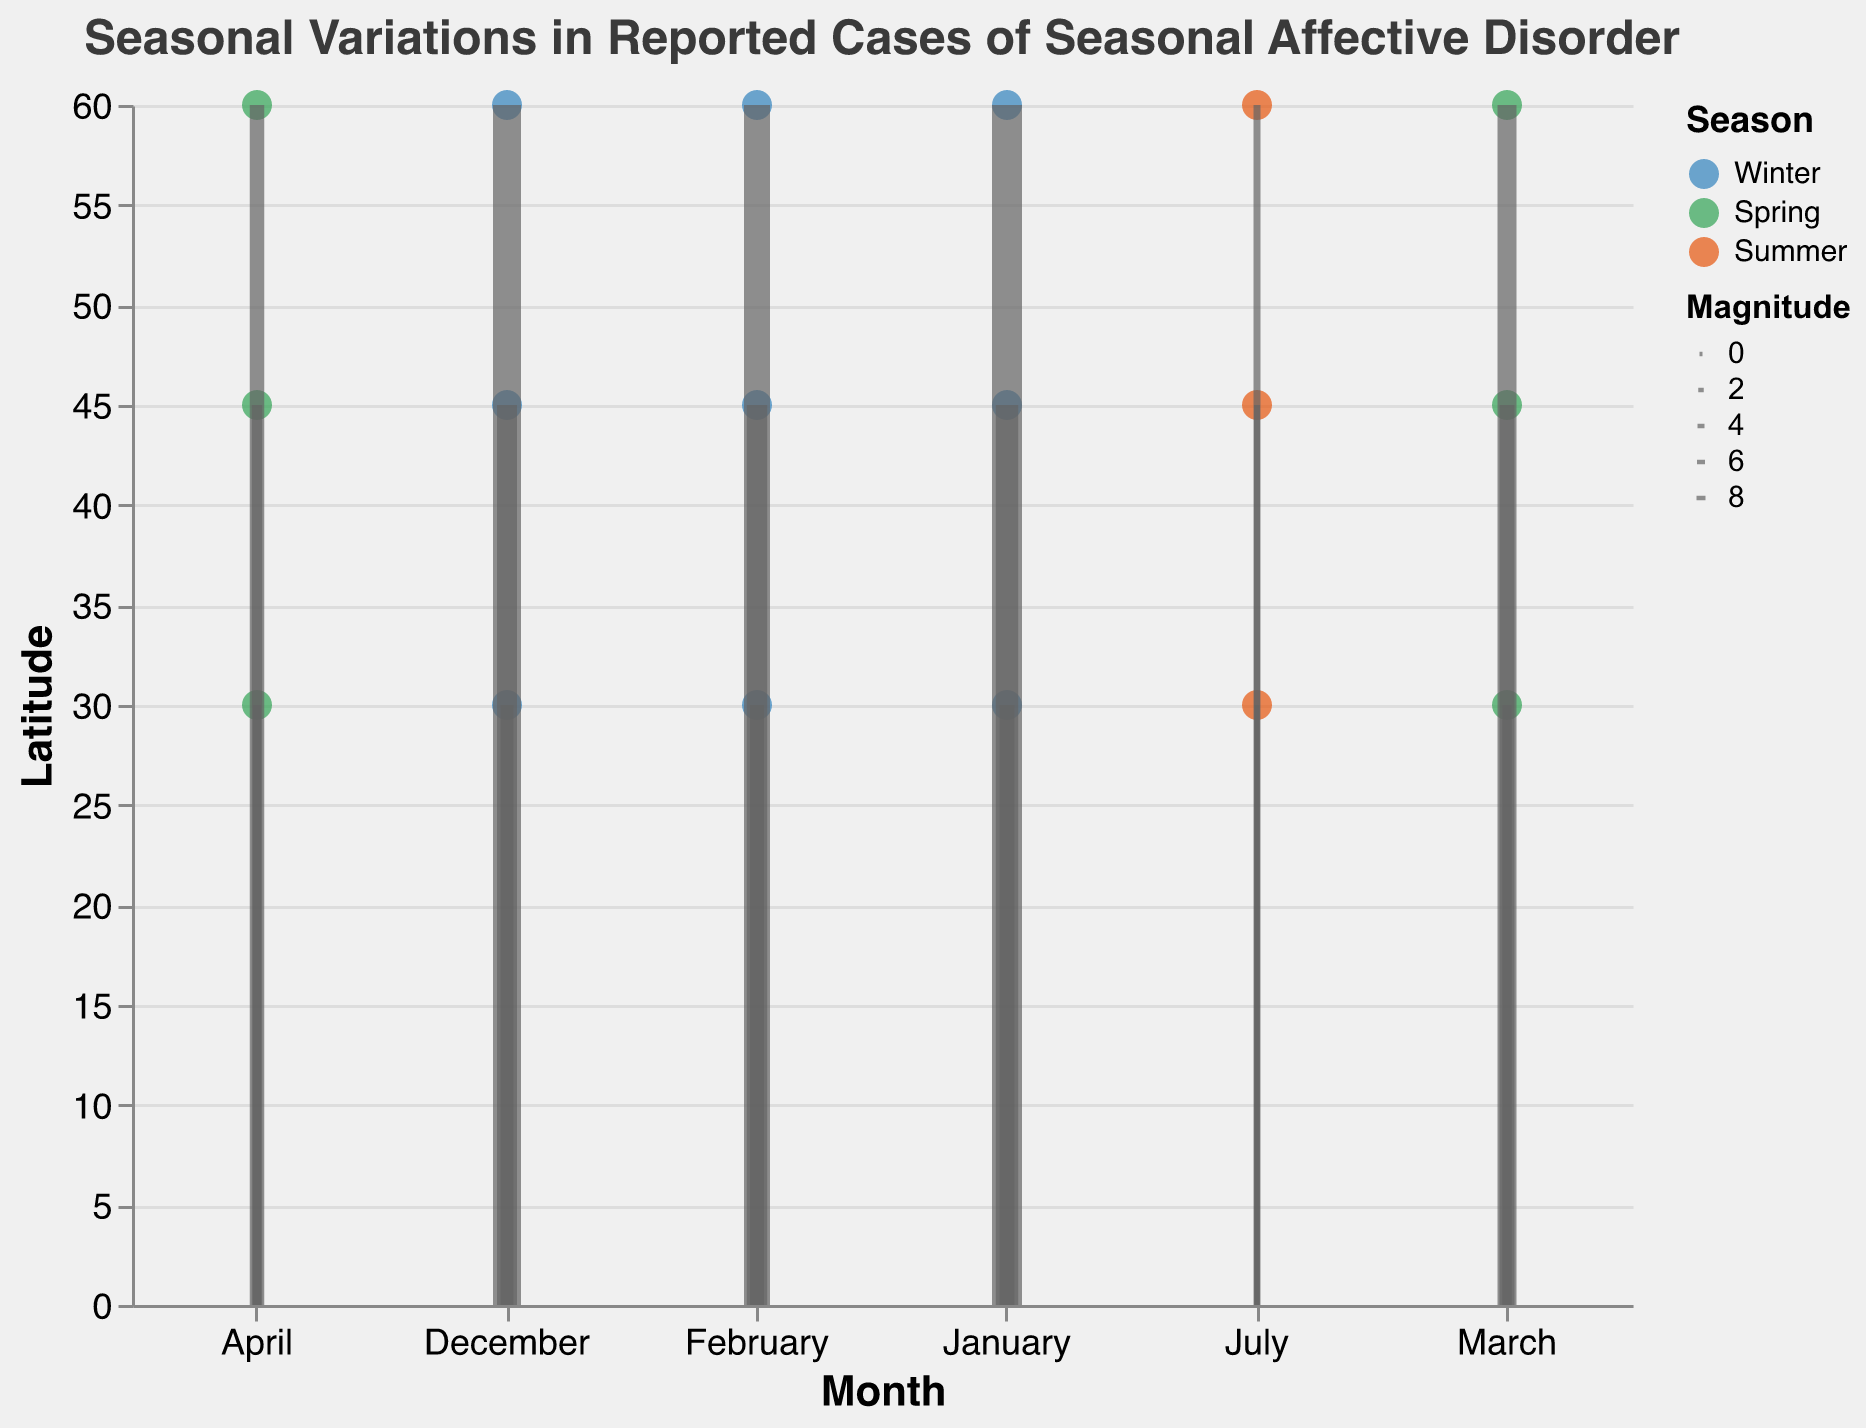What is the title of the figure? The title of the figure is displayed prominently at the top of the plot.
Answer: Seasonal Variations in Reported Cases of Seasonal Affective Disorder How is the 'Direction' of wind visualized in the figure? The 'Direction' is visualized through the orientation of the wind vector arrows marked as 'rule'. Each direction corresponds to a specific angle: North (0°), Northeast (45°), East (90°), Southeast (135°), South (180°), and Northwest (315°).
Answer: Through the orientation of wind vector arrows Which season has the most reported cases of Seasonal Affective Disorder at latitude 60.0? Checking the colors representing seasons and the values for reported cases at latitude 60.0, the winter season (blue color) shows the highest values in December, January, and February. The highest number of cases is in January.
Answer: Winter Comparing January at latitudes 60.0 and 30.0, which has more reported cases? Look at the points for January at both latitudes. For 60.0 (blue point), reported cases are 187. For 30.0 (blue point), reported cases are 53.
Answer: Latitude 60.0 What month has the lowest number of reported cases of Seasonal Affective Disorder? Checking all months visually, the lowest number of reported cases is observed in July (summer season, orange color) across all latitudes.
Answer: July How many data points are plotted in the figure? Counting all the individual data points plotted for various months and latitudes, there are 18 points corresponding to different months and latitudes.
Answer: 18 During which season and month is the intensity of the disorder lowest at latitude 45.0? Look at the sizes of the points at latitude 45.0. The smallest size point is in July, indicating the lowest intensity during the summer.
Answer: Summer, July What is the direction and magnitude of the wind vector in January at latitude 45.0? Locate the wind vector arrow for January at 45.0. The arrow points towards the North (0°) with a magnitude size represented as 6.1.
Answer: North, 6.1 Which latitude experienced a sharper decrease in reported cases from Winter to Spring? Compare the decrease from Winter (highest) to Spring (decreased) months across latitudes. At latitude 60.0, the drop from Winter to Spring is from 187 to 52. At 45.0, the drop is from 112 to 33. At 30.0, it goes from 53 to 17. The sharpest decrease is observed at latitude 60.0.
Answer: Latitude 60.0 What is the magnitude of the wind vector in February at latitude 30.0? Check the wind vector arrow in February at latitude 30.0. The vector magnitude size is denoted by 3.4.
Answer: 3.4 